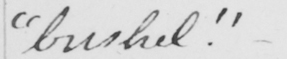Please provide the text content of this handwritten line. "bushel." 